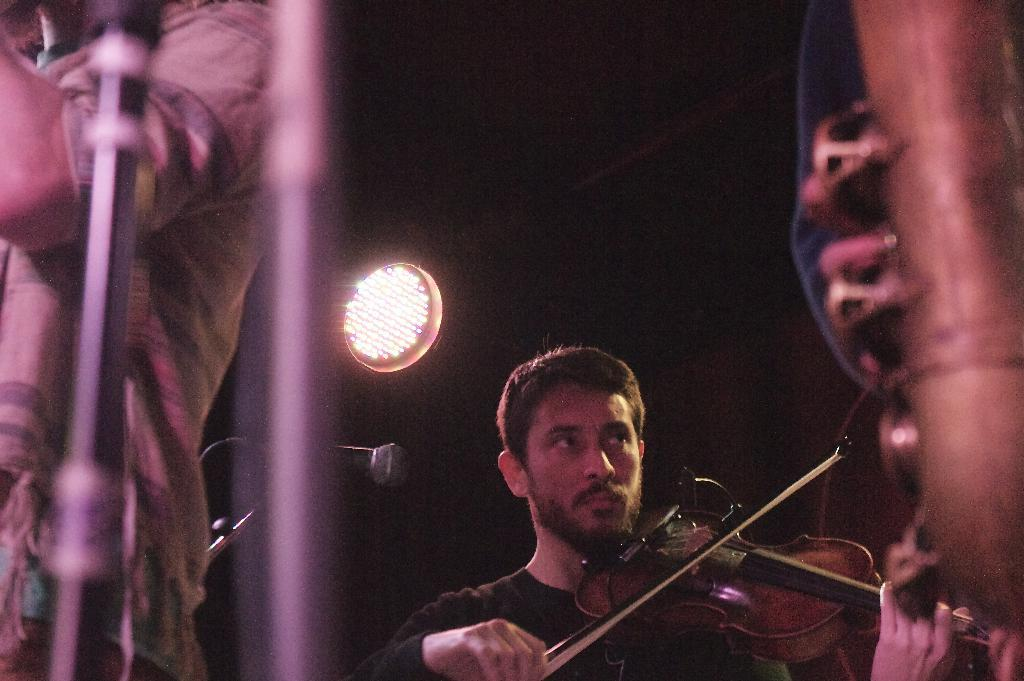What can be seen in the image that provides illumination? There is a light in the image. How many people are present in the image? There are two people in the image. What is one person doing in the image? One person is playing a guitar. What color is the shirt of the person playing the guitar? The person playing the guitar is wearing a black color shirt. What object is present in the image that is typically used for amplifying sound? There is a mic in the image. Is there a bridge visible in the image? No, there is no bridge present in the image. What type of linen is being used by the person playing the guitar? There is no linen mentioned or visible in the image. 